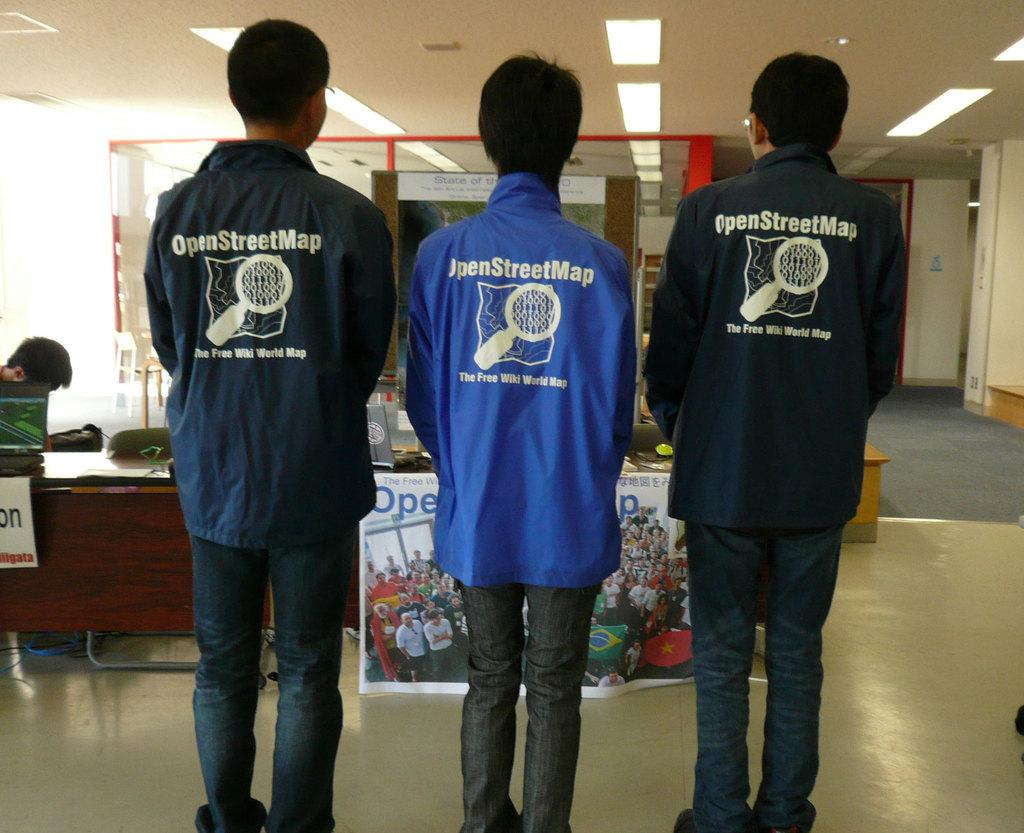<image>
Provide a brief description of the given image. Three people have the same shirt on, it is about an open street map wiki. 